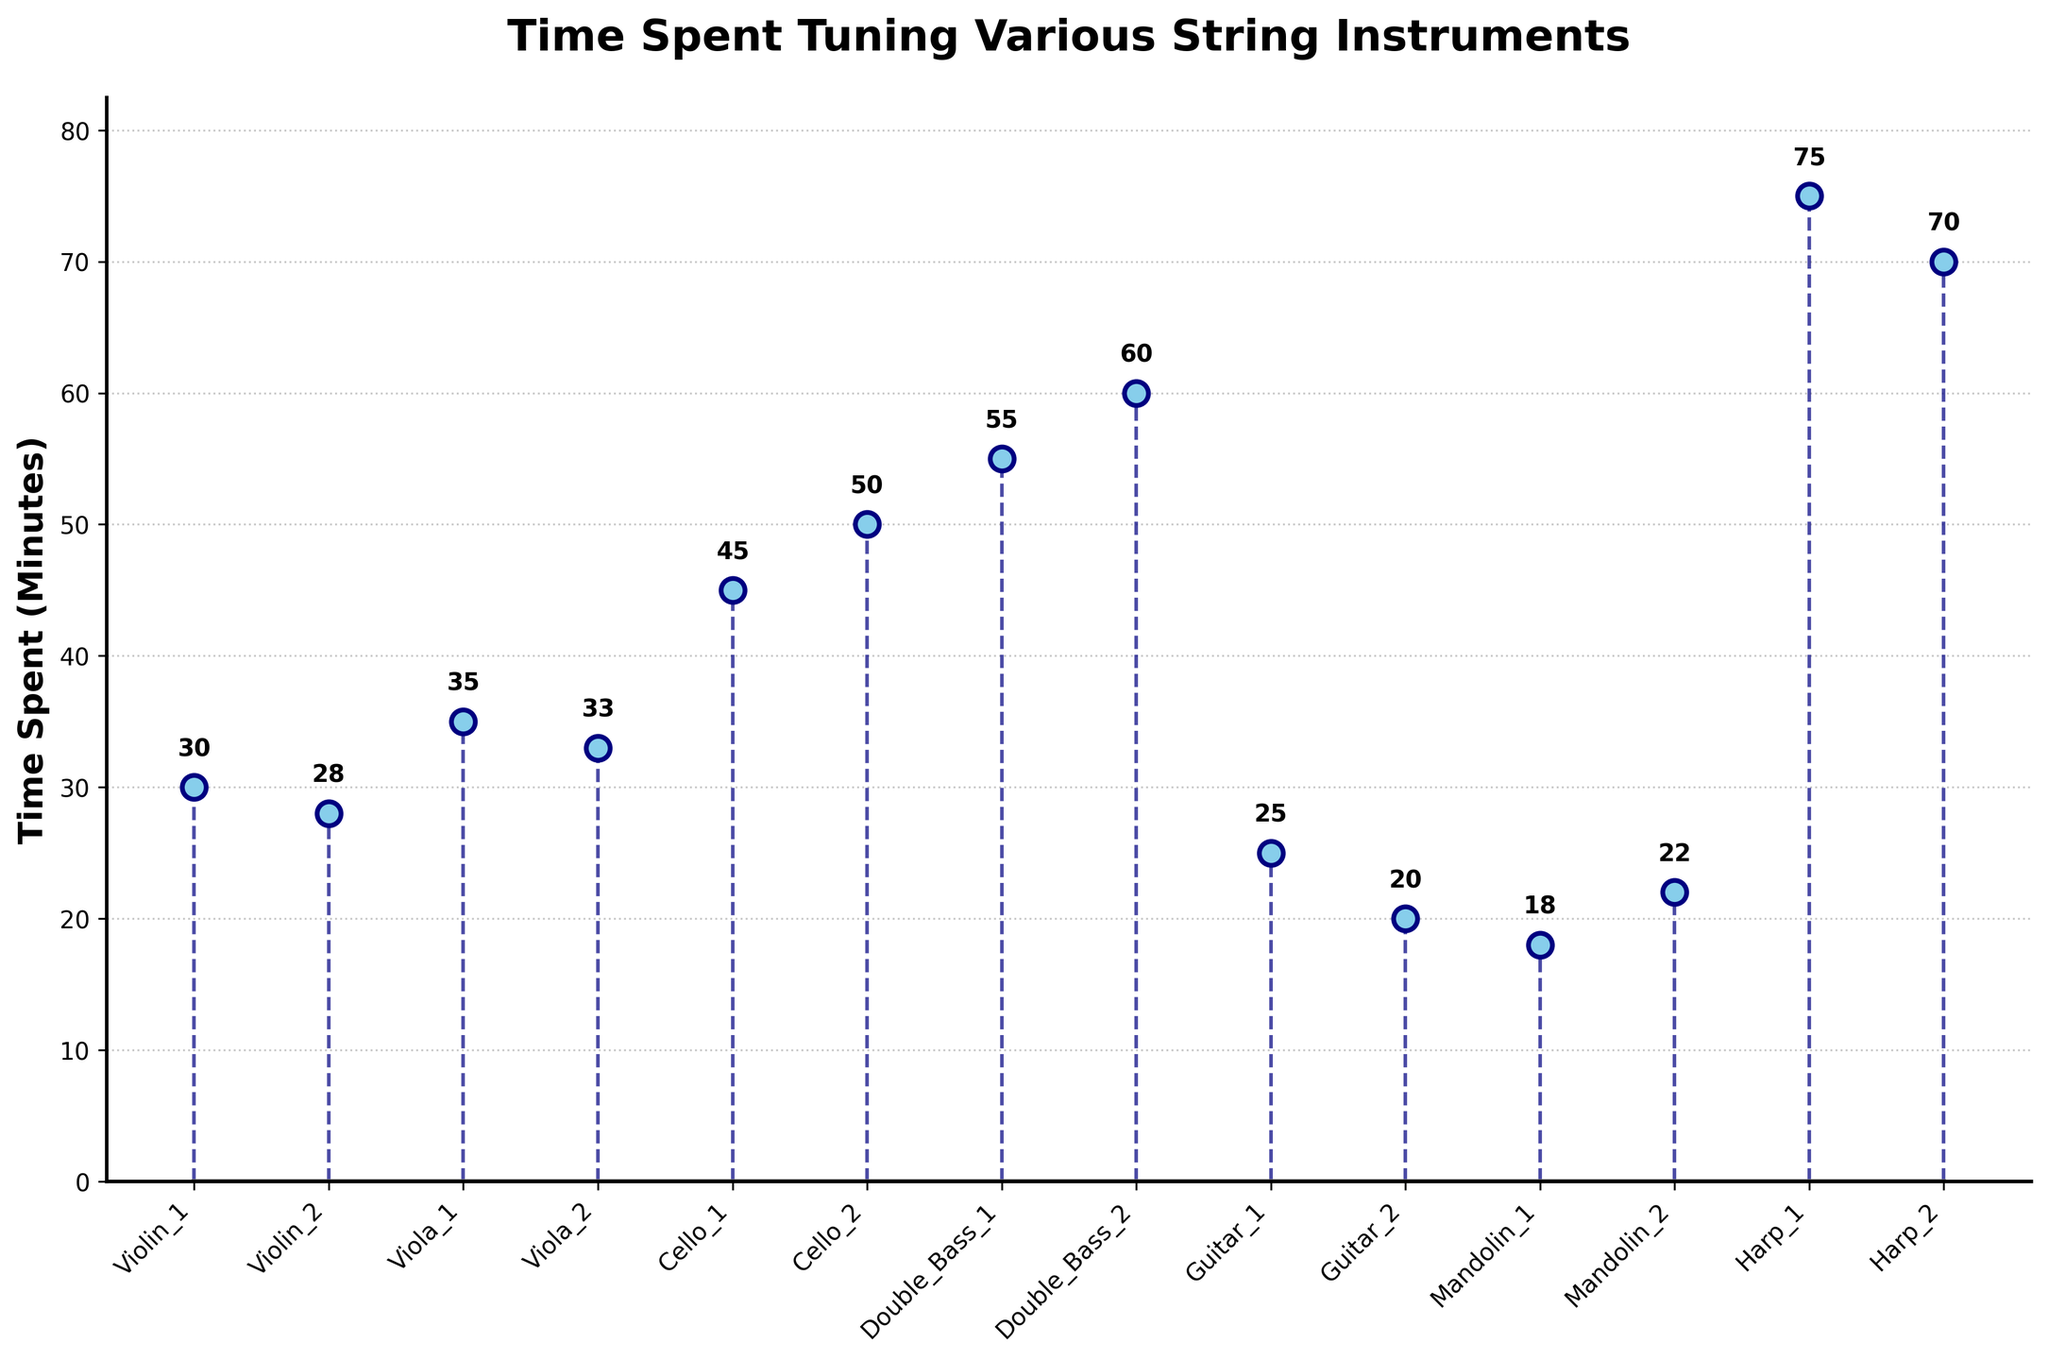What is the title of the plot? The title of the plot is displayed at the top and usually describes what the plot is representing. Here, it reads 'Time Spent Tuning Various String Instruments.'
Answer: 'Time Spent Tuning Various String Instruments' How many types of instruments are represented in the plot? Count the unique instrument types along the x-axis. Here, they are Violin, Viola, Cello, Double Bass, Guitar, Mandolin, and Harp.
Answer: 7 Which instrument takes the most time to tune in a week? Look for the highest y-value (time spent) and identify the corresponding instrument on the x-axis. The harp has the highest value at 75 minutes.
Answer: Harp What are the colors of the markers used in the plot? The colors of the markers can be identified through visual examination. They are described as having navy edges and sky blue faces.
Answer: Navy edge with sky blue face What is the average time spent tuning Violas? There are two data points for Violas: 35 and 33. The average is (35 + 33) / 2.
Answer: (35 + 33) / 2 = 34 Which instrument takes less time to tune, the Mandolin or the Guitar (consider both tuning instances for each)? Sum the times for each instrument and compare: Mandolin has 18 and 22 minutes (total 40 minutes) while Guitar has 25 and 20 minutes (total 45 minutes). So, Mandolin takes less time.
Answer: Mandolin What is the median time spent tuning the instruments? First, list all durations in ascending order: 18, 20, 22, 25, 28, 30, 33, 35, 45, 50, 55, 60, 70, 75. The median is the middle value in this list. As there are 14 values, take the average of the 7th and 8th values: (33 + 35) / 2.
Answer: (33 + 35) / 2 = 34 What is the total time spent tuning all instruments in a week? Sum up all the time values: 30 + 28 + 35 + 33 + 45 + 50 + 55 + 60 + 25 + 20 + 18 + 22 + 75 + 70.
Answer: 566 minutes How does the time spent tuning the highest and lowest instruments compare? Identify the highest (75 minutes for Harp) and the lowest (18 minutes for Mandolin) times. The difference is 75 - 18. Harp takes 57 minutes more than Mandolin.
Answer: 57 minutes What is the range of the data set (difference between the highest and lowest values)? The highest value is 75 (Harp), and the lowest is 18 (Mandolin). The range is 75 - 18.
Answer: 57 